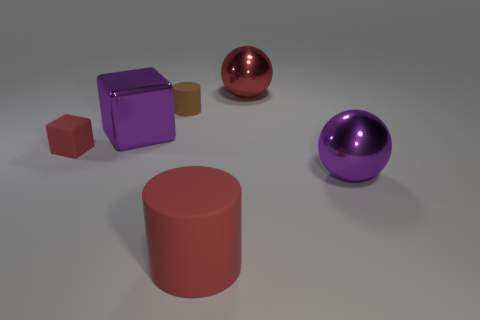The large metallic object that is the same shape as the small red rubber object is what color?
Give a very brief answer. Purple. There is a cylinder that is the same color as the rubber block; what is it made of?
Ensure brevity in your answer.  Rubber. Are there any other objects of the same shape as the tiny brown matte thing?
Make the answer very short. Yes. Are there any red objects in front of the sphere that is behind the purple metallic sphere?
Keep it short and to the point. Yes. How many other things are the same color as the metal block?
Give a very brief answer. 1. Do the purple metallic object that is to the left of the small brown matte cylinder and the cylinder behind the tiny red matte block have the same size?
Your answer should be compact. No. How big is the cylinder behind the large red object in front of the large red shiny ball?
Ensure brevity in your answer.  Small. What is the material of the object that is both behind the purple block and to the left of the red shiny object?
Offer a very short reply. Rubber. The matte cube is what color?
Make the answer very short. Red. What is the shape of the big purple shiny thing right of the red metal sphere?
Your response must be concise. Sphere. 